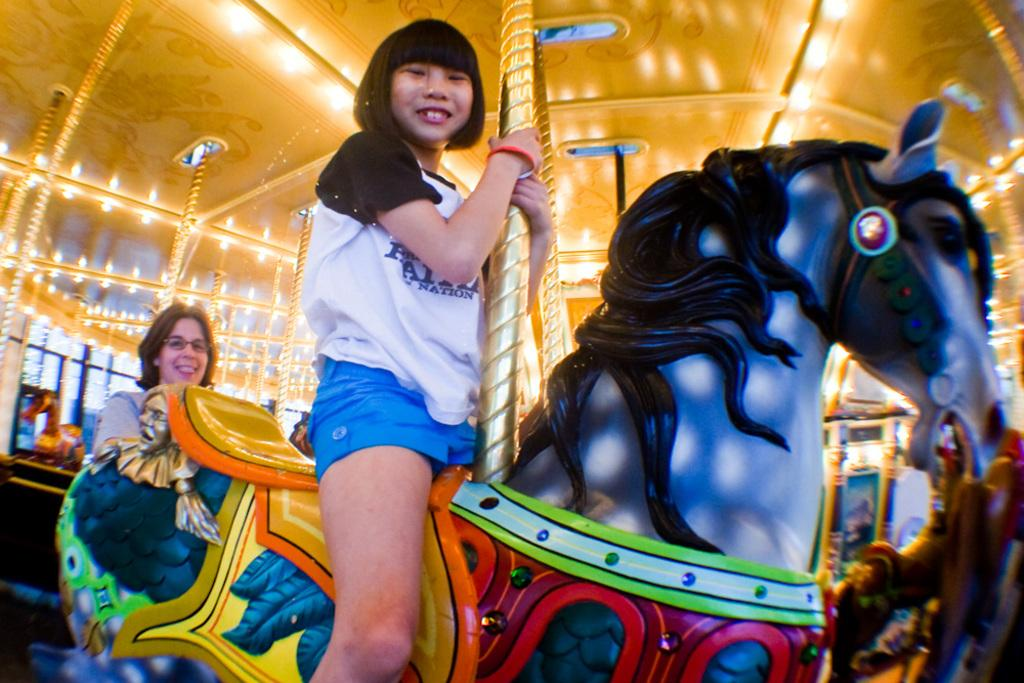How many women are in the image? There are two women in the image. What is the position of one of the women in the image? One of the women is sitting on an object. What is the facial expression of the woman who is sitting? The woman who is sitting is smiling. What type of gold tooth can be seen in the image? There is no tooth, gold or otherwise, present in the image. What is the limit of the women's abilities in the image? The image does not provide information about the women's abilities or any limits on them. 